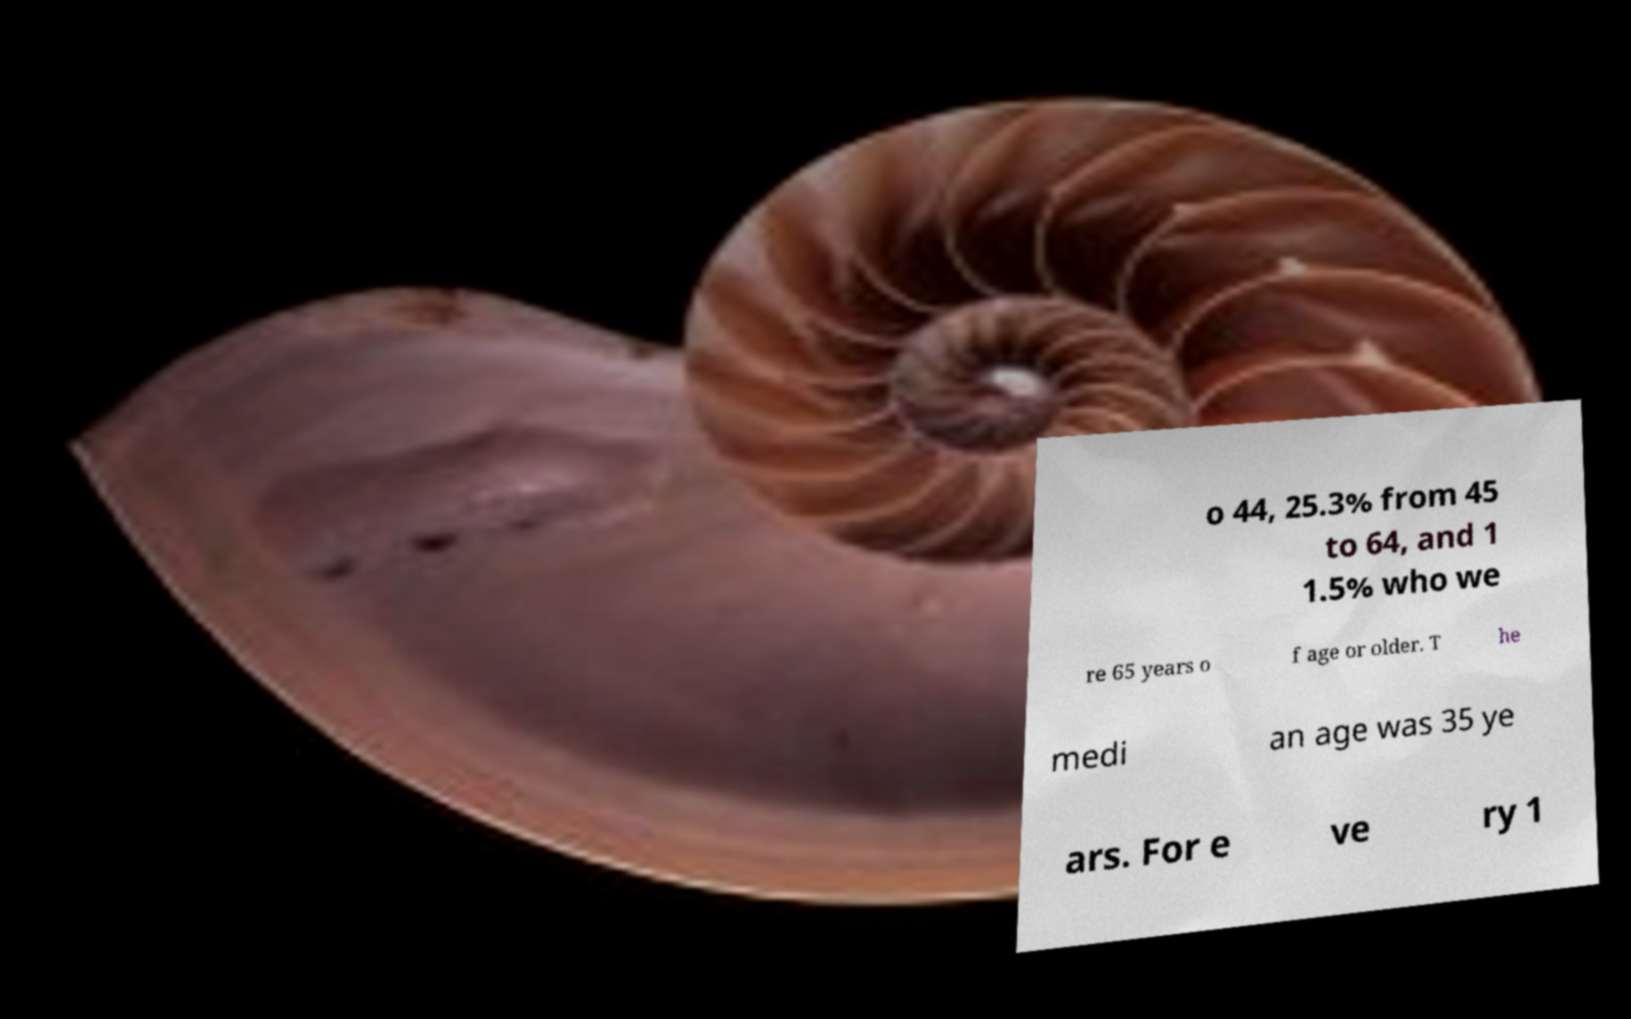For documentation purposes, I need the text within this image transcribed. Could you provide that? o 44, 25.3% from 45 to 64, and 1 1.5% who we re 65 years o f age or older. T he medi an age was 35 ye ars. For e ve ry 1 